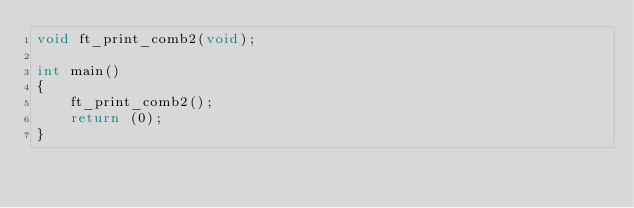<code> <loc_0><loc_0><loc_500><loc_500><_C_>void ft_print_comb2(void);

int main()
{	
	ft_print_comb2();
	return (0);
}</code> 